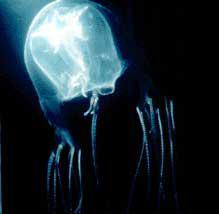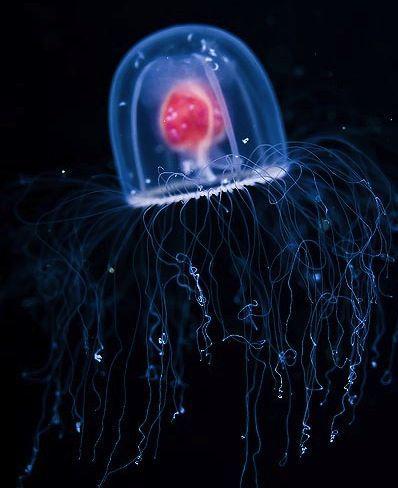The first image is the image on the left, the second image is the image on the right. Assess this claim about the two images: "The inside of the jellyfish's body is a different color.". Correct or not? Answer yes or no. Yes. 